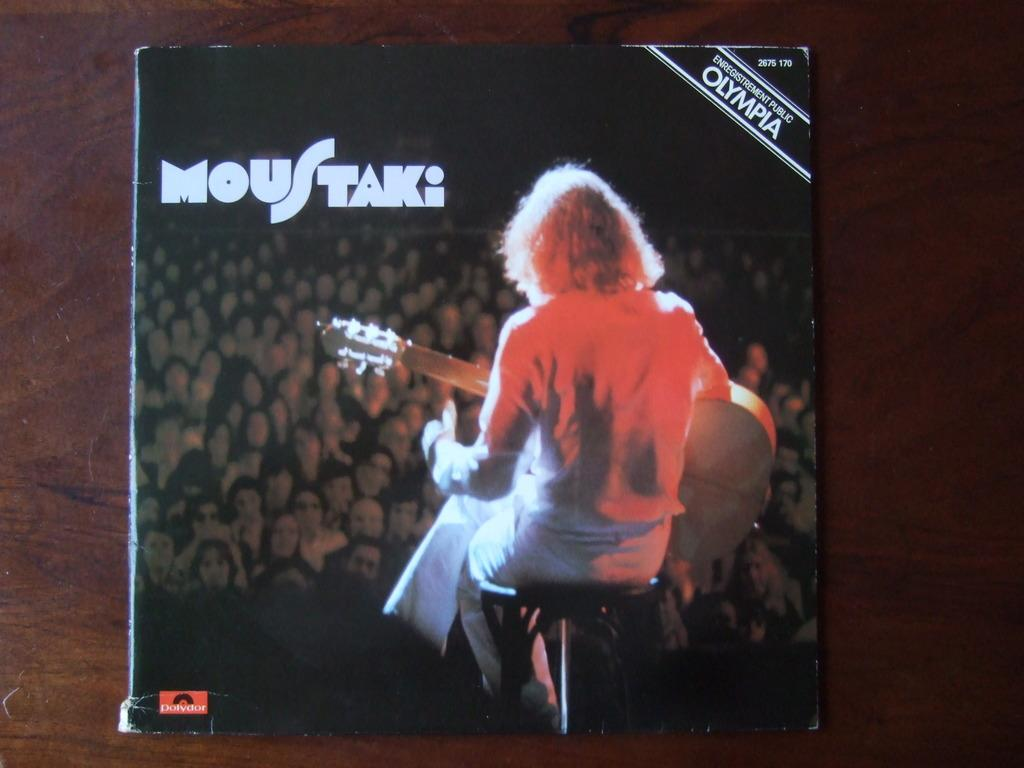<image>
Offer a succinct explanation of the picture presented. Olympia album cover for MousTaki she is sitting with a guitar for the audience. 